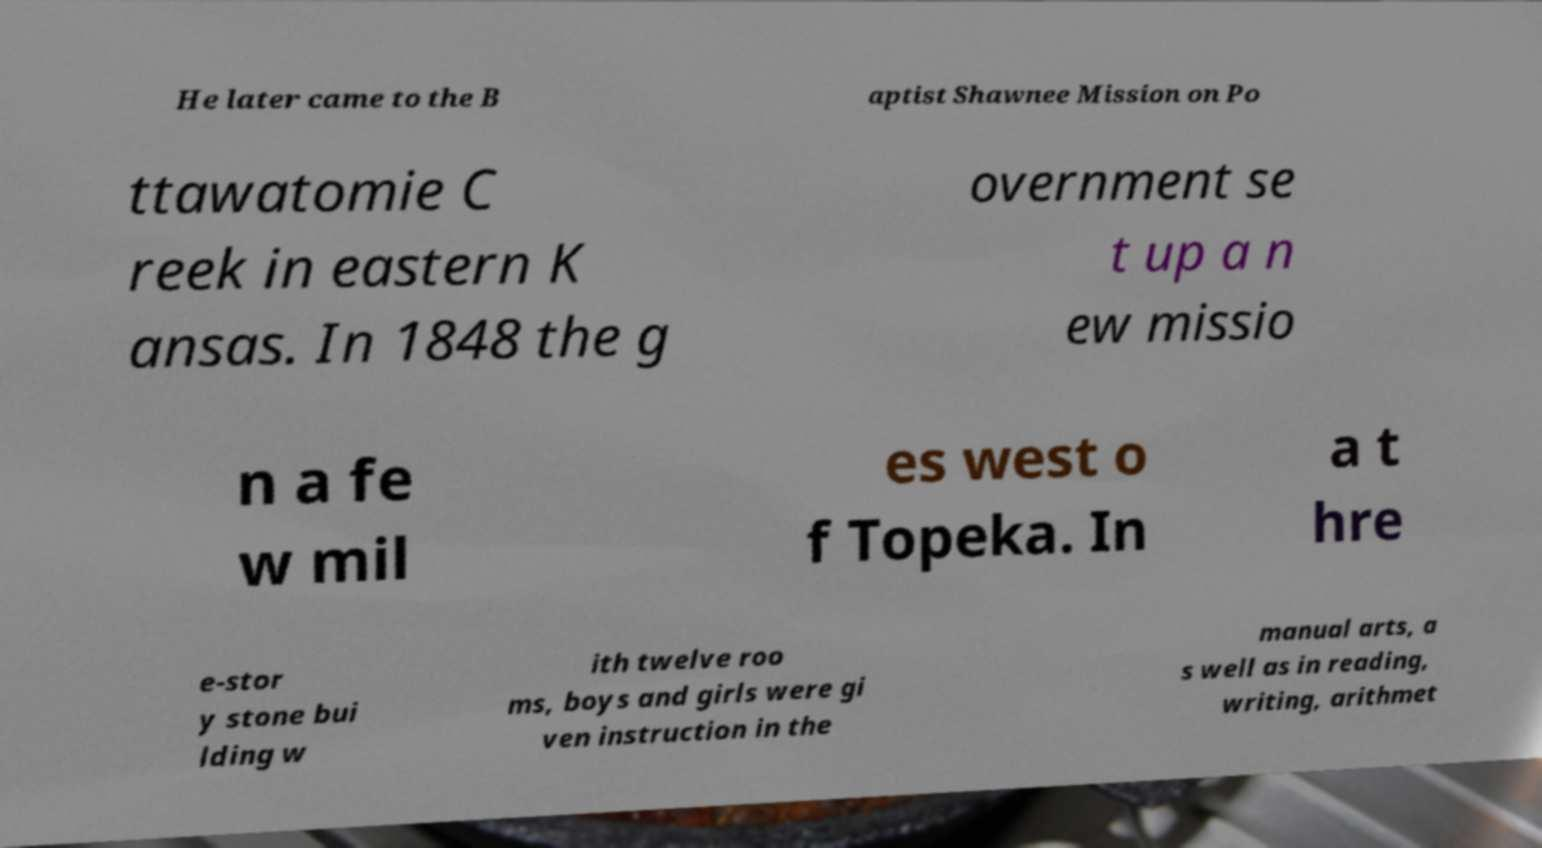Can you accurately transcribe the text from the provided image for me? He later came to the B aptist Shawnee Mission on Po ttawatomie C reek in eastern K ansas. In 1848 the g overnment se t up a n ew missio n a fe w mil es west o f Topeka. In a t hre e-stor y stone bui lding w ith twelve roo ms, boys and girls were gi ven instruction in the manual arts, a s well as in reading, writing, arithmet 